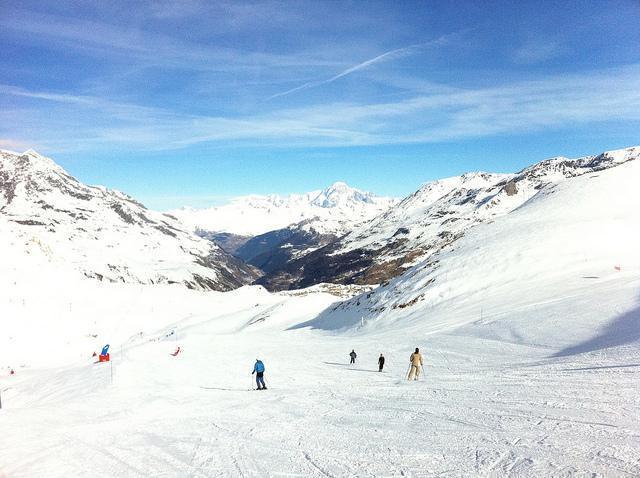What type of sport is this?
Select the accurate response from the four choices given to answer the question.
Options: Winter, tropical, summer, aquatic. Winter. 